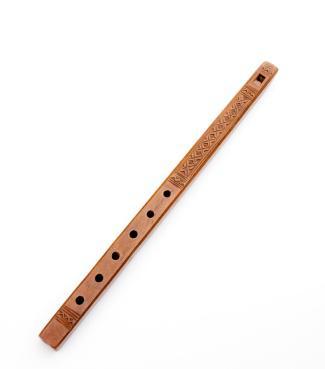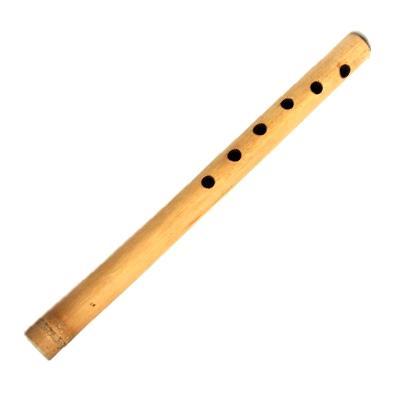The first image is the image on the left, the second image is the image on the right. Evaluate the accuracy of this statement regarding the images: "The flutes displayed on the left and right angle toward each other, and the flute on the right is decorated with tribal motifs.". Is it true? Answer yes or no. No. The first image is the image on the left, the second image is the image on the right. Considering the images on both sides, is "Both flutes are angled from bottom left to top right." valid? Answer yes or no. Yes. 